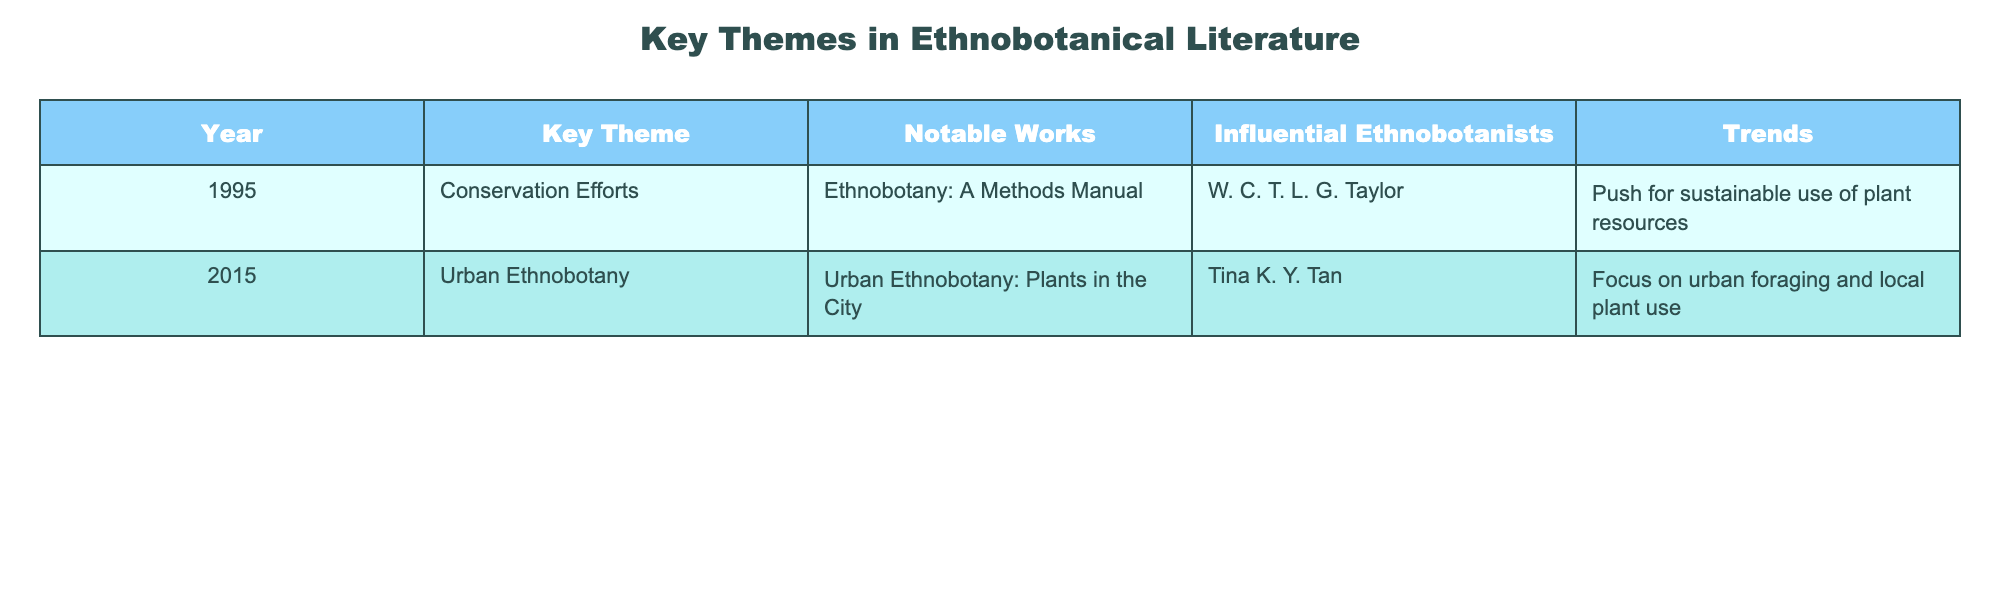What year did notable works focusing on urban ethnobotany emerge? The table shows that "Urban Ethnobotany: Plants in the City" was published in 2015, indicating that this year is when significant works in urban ethnobotany emerged.
Answer: 2015 Who is the influential ethnobotanist associated with conservation efforts in 1995? According to the table, W. C. T. L. G. Taylor is listed under notable works related to conservation efforts, indicating he is the influential ethnobotanist for that theme in 1995.
Answer: W. C. T. L. G. Taylor Based on the table, did urban ethnobotany gain prominence before conservation efforts? The table shows that conservation efforts were highlighted in 1995, while urban ethnobotany gained attention in 2015, confirming that urban ethnobotany emerged later.
Answer: No What key theme relates to sustainable use of plant resources, and in what year was it noted? The table indicates that the key theme related to sustainable use of plant resources is conservation efforts, which were noted in 1995.
Answer: Conservation efforts, 1995 Calculate the number of years between the key themes of conservation efforts and urban ethnobotany. The table lists conservation efforts in 1995 and urban ethnobotany in 2015. To find the difference, subtract 1995 from 2015, which equals 20 years.
Answer: 20 years Is Tina K. Y. Tan associated with conservation efforts mentioned in the table? The table indicates that conservation efforts are linked to W. C. T. L. G. Taylor, while Tina K. Y. Tan is associated with urban ethnobotany, confirming she is not linked with conservation efforts.
Answer: No What trend is associated with urban ethnobotany according to the table? The table lists the trend associated with urban ethnobotany as the focus on urban foraging and local plant use, indicating the key theme's direction.
Answer: Focus on urban foraging and local plant use Which notable work was published in 1995, and who authored it? The table states that "Ethnobotany: A Methods Manual" was the notable work published in 1995, and it was authored by W. C. T. L. G. Taylor.
Answer: "Ethnobotany: A Methods Manual" by W. C. T. L. G. Taylor Are both key themes mentioned in the table interconnected in terms of sustainability? The table shows that both conservation efforts and urban ethnobotany can relate to sustainability, as conservation aims at sustainable use and urban ethnobotany focuses on local plant use, indicating some interconnection.
Answer: Yes 